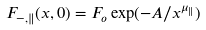Convert formula to latex. <formula><loc_0><loc_0><loc_500><loc_500>F _ { - , \| } ( x , 0 ) = F _ { o } \exp ( - A / x ^ { \mu _ { \| } } )</formula> 